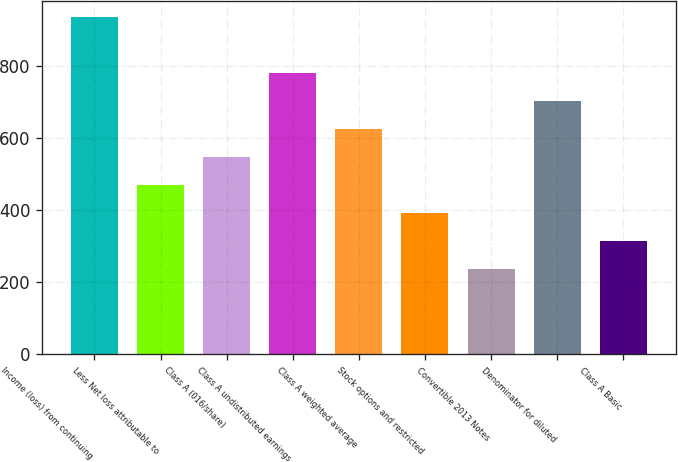Convert chart. <chart><loc_0><loc_0><loc_500><loc_500><bar_chart><fcel>Income (loss) from continuing<fcel>Less Net loss attributable to<fcel>Class A (016/share)<fcel>Class A undistributed earnings<fcel>Class A weighted average<fcel>Stock options and restricted<fcel>Convertible 2013 Notes<fcel>Denominator for diluted<fcel>Class A Basic<nl><fcel>935.63<fcel>468.77<fcel>546.58<fcel>780.01<fcel>624.39<fcel>390.96<fcel>235.34<fcel>702.2<fcel>313.15<nl></chart> 